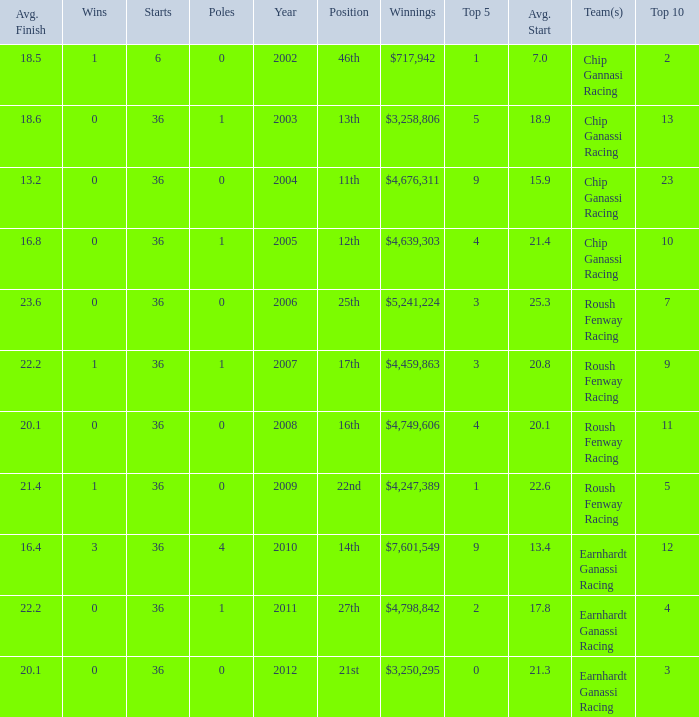Name the starts when position is 16th 36.0. 